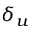<formula> <loc_0><loc_0><loc_500><loc_500>\delta _ { u }</formula> 